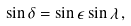Convert formula to latex. <formula><loc_0><loc_0><loc_500><loc_500>\sin \delta = \sin \epsilon \sin \lambda \, ,</formula> 